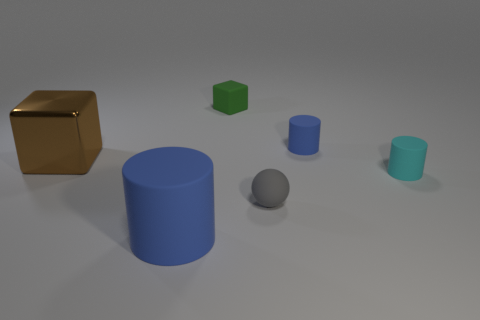Add 4 blue things. How many objects exist? 10 Subtract all blocks. How many objects are left? 4 Add 2 large cyan cylinders. How many large cyan cylinders exist? 2 Subtract 0 blue balls. How many objects are left? 6 Subtract all tiny rubber blocks. Subtract all large cubes. How many objects are left? 4 Add 2 tiny green things. How many tiny green things are left? 3 